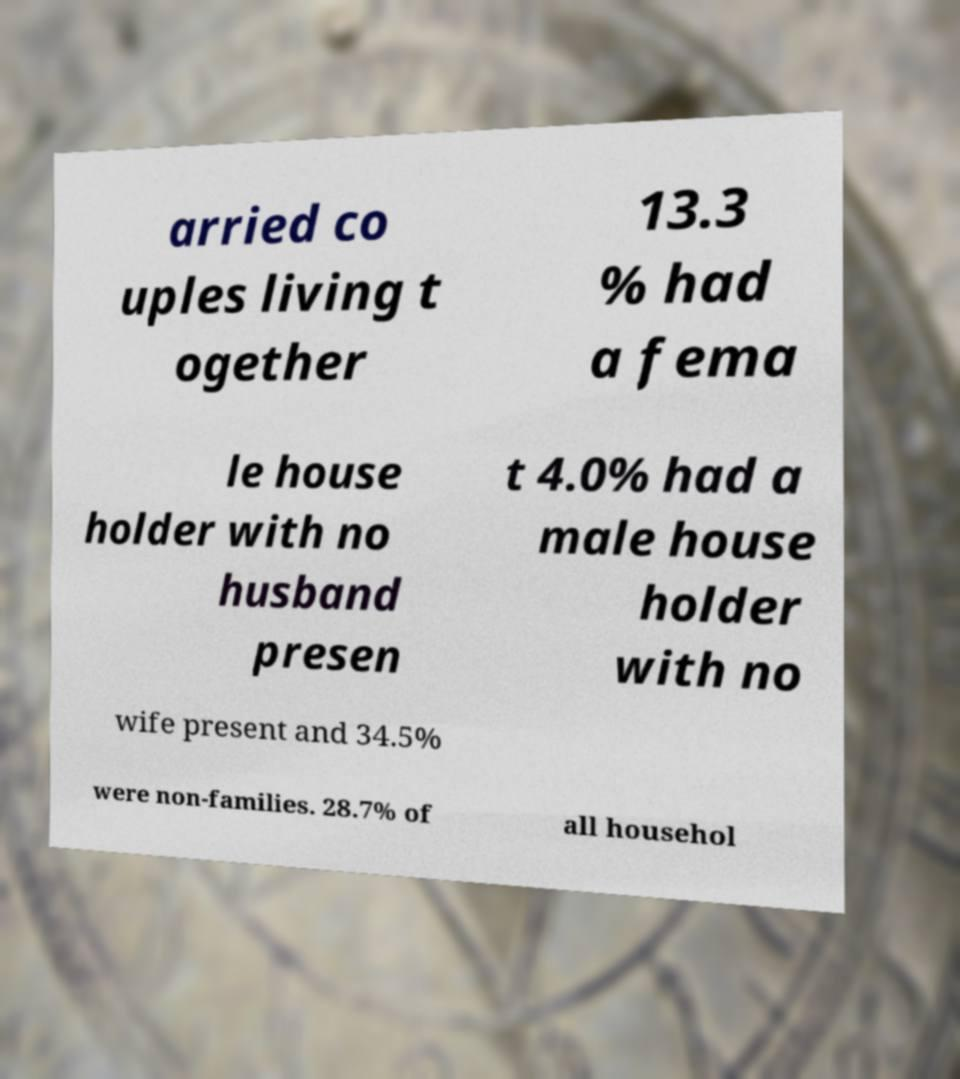Could you assist in decoding the text presented in this image and type it out clearly? arried co uples living t ogether 13.3 % had a fema le house holder with no husband presen t 4.0% had a male house holder with no wife present and 34.5% were non-families. 28.7% of all househol 